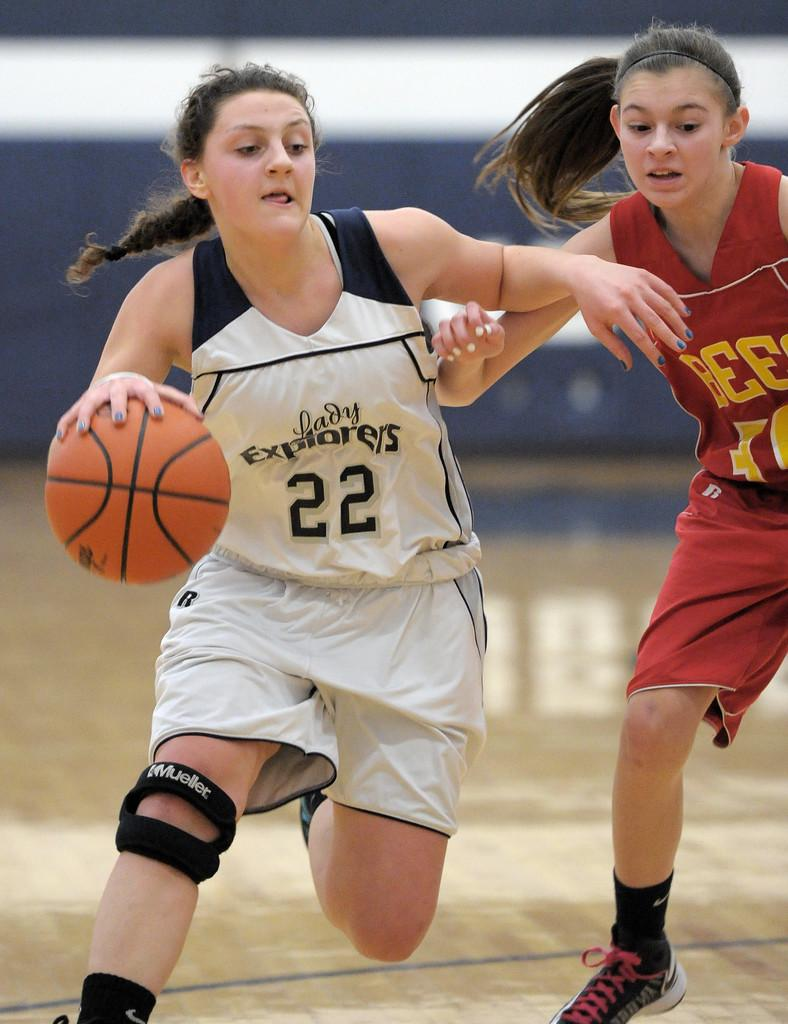<image>
Render a clear and concise summary of the photo. The girl who is dribbling the ball is wearing a Lady Explorers jersey 